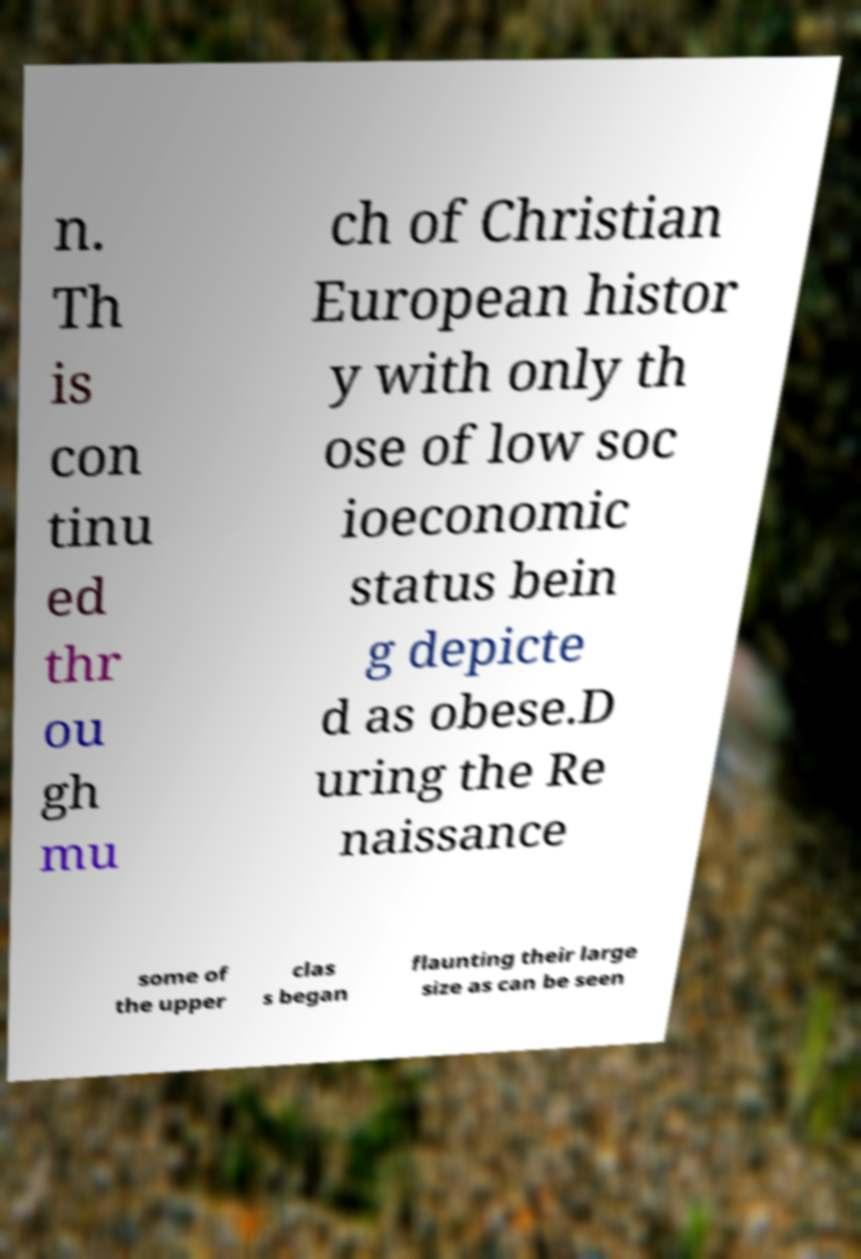Could you extract and type out the text from this image? n. Th is con tinu ed thr ou gh mu ch of Christian European histor y with only th ose of low soc ioeconomic status bein g depicte d as obese.D uring the Re naissance some of the upper clas s began flaunting their large size as can be seen 